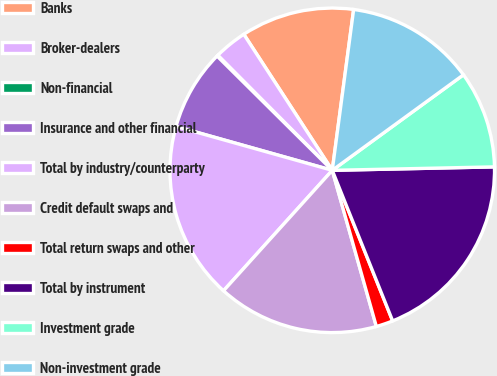Convert chart. <chart><loc_0><loc_0><loc_500><loc_500><pie_chart><fcel>Banks<fcel>Broker-dealers<fcel>Non-financial<fcel>Insurance and other financial<fcel>Total by industry/counterparty<fcel>Credit default swaps and<fcel>Total return swaps and other<fcel>Total by instrument<fcel>Investment grade<fcel>Non-investment grade<nl><fcel>11.28%<fcel>3.29%<fcel>0.1%<fcel>8.08%<fcel>17.67%<fcel>16.07%<fcel>1.69%<fcel>19.27%<fcel>9.68%<fcel>12.88%<nl></chart> 